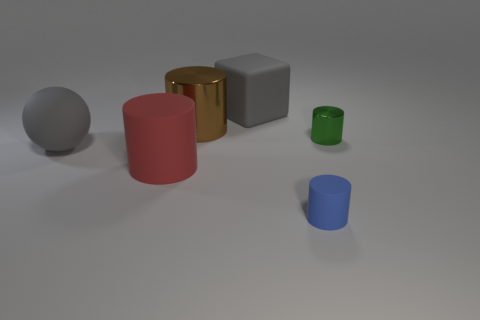The rubber thing that is on the right side of the large metallic thing and left of the blue rubber cylinder is what color?
Provide a succinct answer. Gray. Is the shape of the big red rubber object the same as the green metallic object?
Keep it short and to the point. Yes. What size is the rubber object that is the same color as the rubber cube?
Provide a short and direct response. Large. What shape is the big gray object to the left of the thing behind the brown object?
Provide a short and direct response. Sphere. There is a green metallic thing; is its shape the same as the gray object that is to the left of the block?
Offer a terse response. No. What is the color of the other cylinder that is the same size as the blue rubber cylinder?
Your response must be concise. Green. Are there fewer brown cylinders that are in front of the green cylinder than gray matte blocks that are in front of the red object?
Keep it short and to the point. No. The matte object behind the tiny cylinder that is behind the large gray thing that is in front of the gray block is what shape?
Your answer should be compact. Cube. Does the cylinder behind the small metallic cylinder have the same color as the tiny object in front of the small metal cylinder?
Provide a succinct answer. No. What shape is the thing that is the same color as the large rubber cube?
Your answer should be very brief. Sphere. 